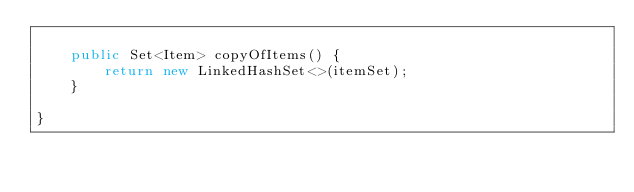Convert code to text. <code><loc_0><loc_0><loc_500><loc_500><_Java_>
    public Set<Item> copyOfItems() {
        return new LinkedHashSet<>(itemSet);
    }

}
</code> 